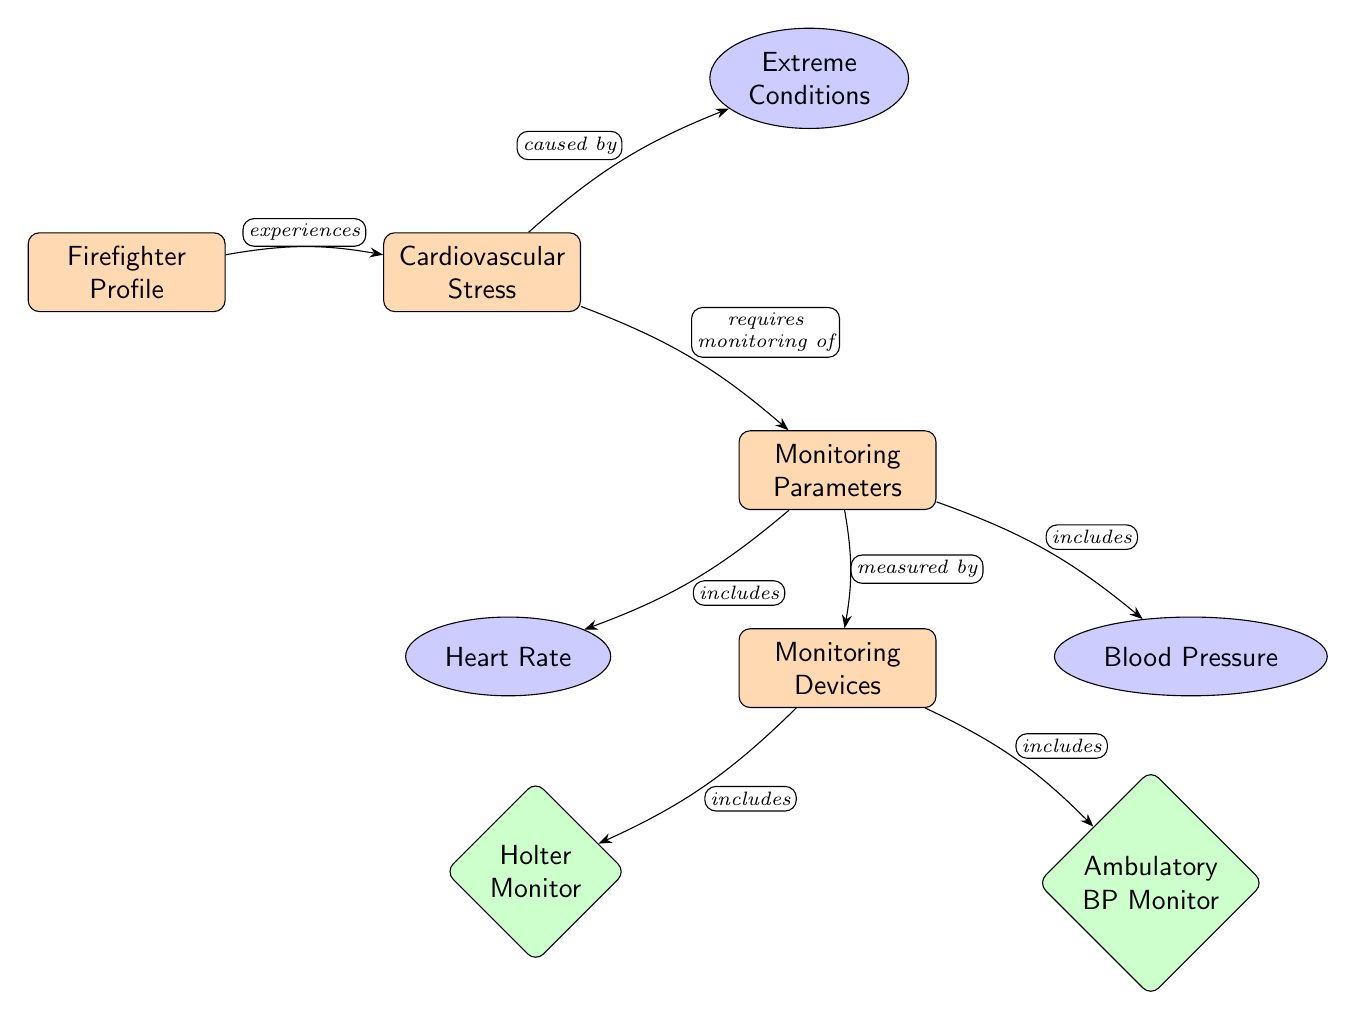What is the main subject of the diagram? The main subject of the diagram is highlighted at the top as "Cardiovascular Stress." This is the central concept being explored, connecting to the firefighter's profile and monitoring.
Answer: Cardiovascular Stress How many types of monitoring parameters are included? The monitoring parameters are listed as "Heart Rate" and "Blood Pressure." Therefore, there are two types included in the diagram.
Answer: 2 What are the devices used for monitoring cardiovascular stress? The monitoring devices are specifically mentioned as "Holter Monitor" and "Ambulatory BP Monitor." These are the devices used to assess the parameters.
Answer: Holter Monitor, Ambulatory BP Monitor Which node connects the "Firefighter Profile" to "Cardiovascular Stress"? The connection from "Firefighter Profile" to "Cardiovascular Stress" is established through the edge labeled "experiences." This relationship indicates how the firefighter's profile influences cardiovascular stress.
Answer: experiences What requires monitoring in the context of cardiovascular stress? The diagram indicates that "Cardiovascular Stress" requires "Monitoring Parameters." This implies the necessity for assessments related to heart rate and blood pressure.
Answer: Monitoring Parameters What is the relationship between "Cardiovascular Stress" and "Extreme Conditions"? The edge labeled "caused by" shows that "Cardiovascular Stress" is directly associated with "Extreme Conditions," indicating circumstances that lead to increased stress.
Answer: caused by How are heart rate and blood pressure categorized in the diagram? Both "Heart Rate" and "Blood Pressure" are categorized as sub-nodes under "Monitoring Parameters," illustrating that they are key components of cardiovascular monitoring.
Answer: sub-nodes Which node signifies the need for continuous monitoring of blood pressure? The node "Ambulatory BP Monitor" represents the need for continuous blood pressure monitoring, reflecting the relevance of this device in such extreme conditions.
Answer: Ambulatory BP Monitor How does the diagram illustrate the flow of information? The diagram uses arrows as edges to illustrate the flow of information from one node to another, showing how concepts are interconnected, such as the influence of firefighter experience on cardiovascular stress.
Answer: Arrows 